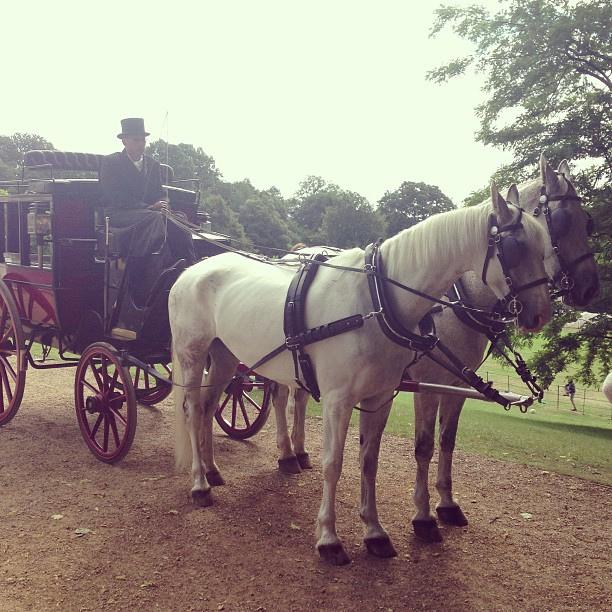What is on the man's head?
Short answer required. Hat. How many horses are there?
Answer briefly. 2. Is one of the horses likely to leave the other behind?
Answer briefly. No. 